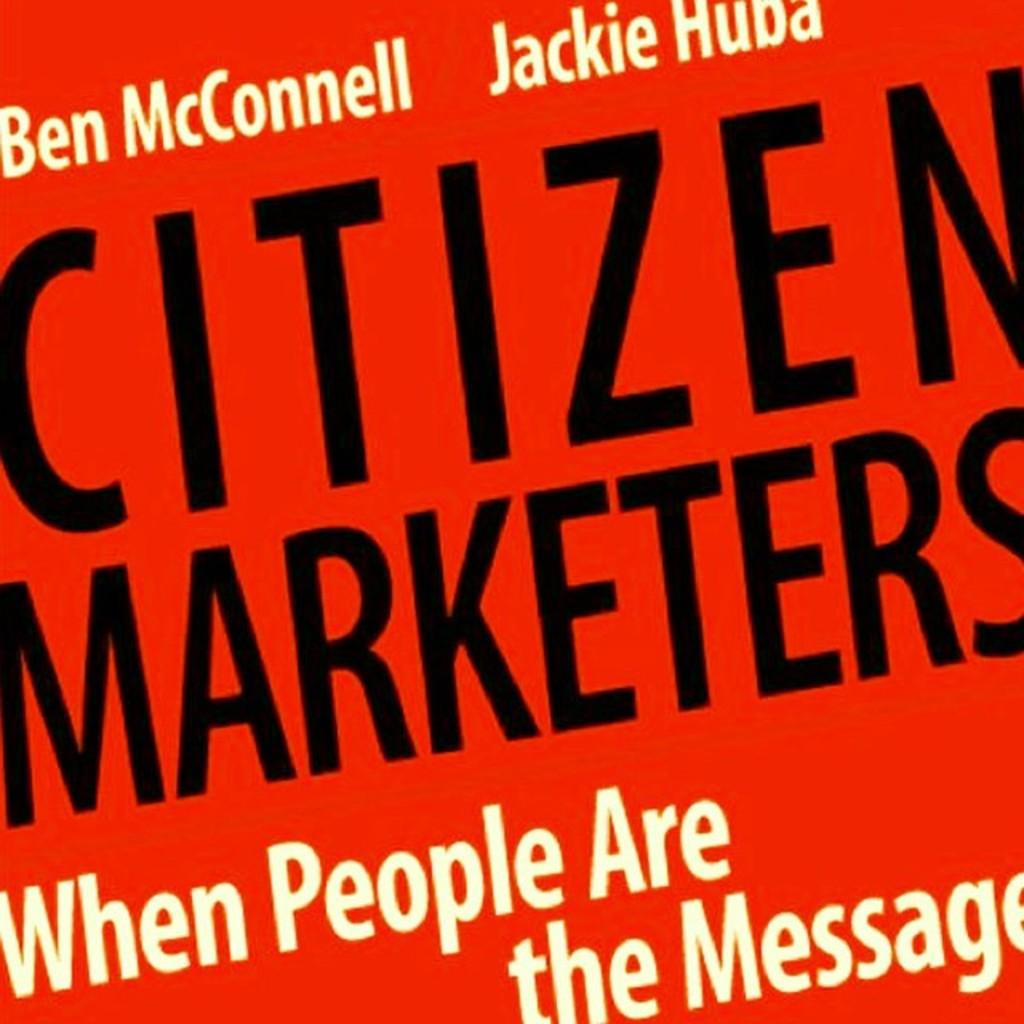<image>
Share a concise interpretation of the image provided. The book Citizen Marketers is written by Ben McConnell and Jackie Huba. 